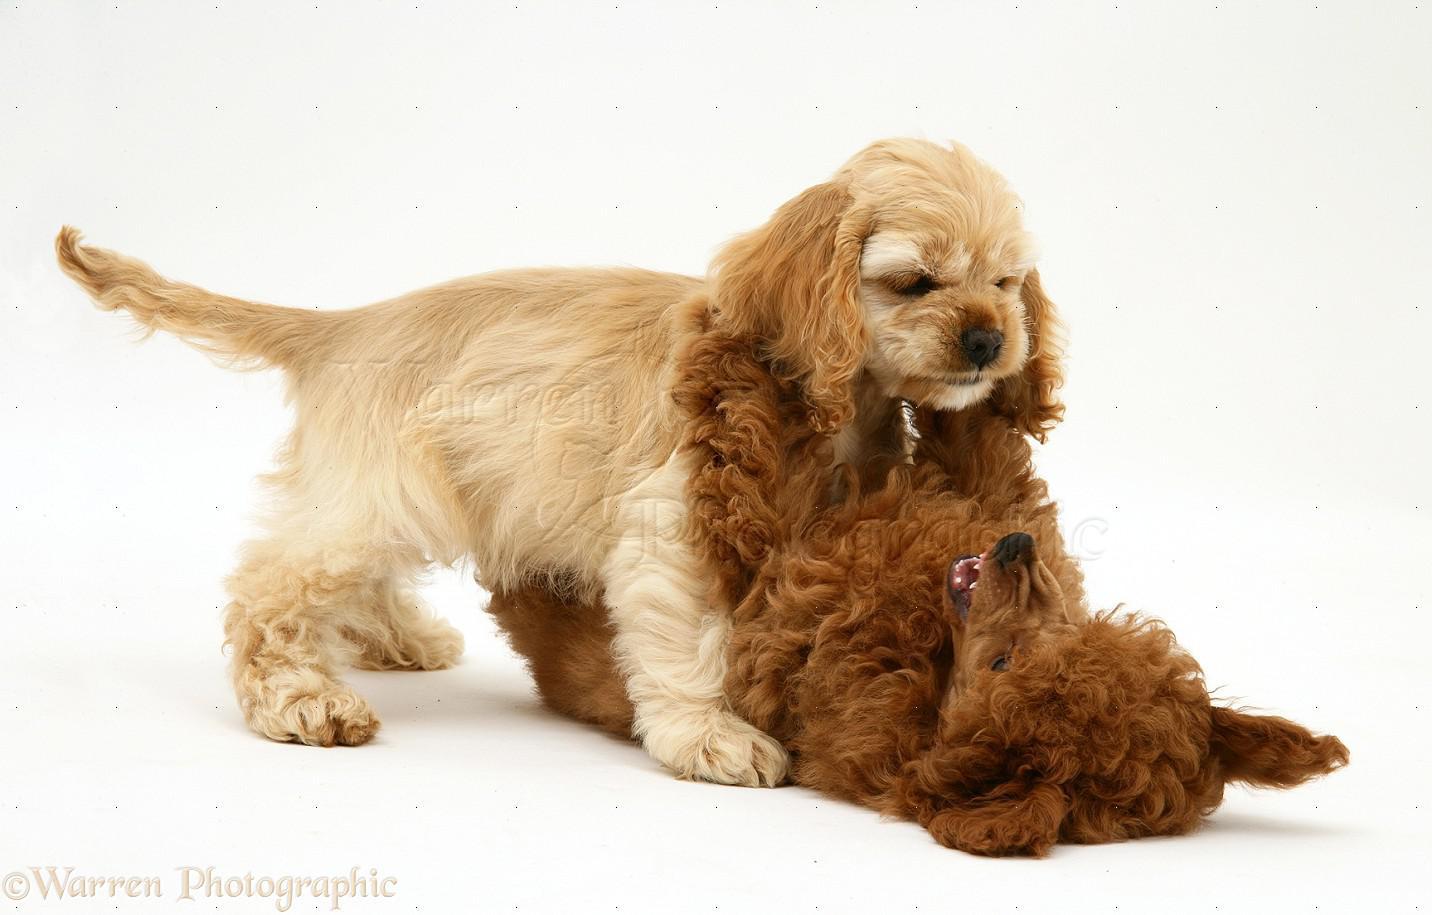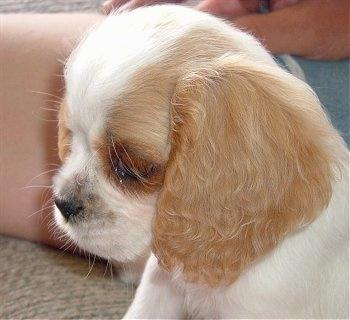The first image is the image on the left, the second image is the image on the right. Given the left and right images, does the statement "There is a young tan puppy on top of a curlyhaired brown puppy." hold true? Answer yes or no. Yes. The first image is the image on the left, the second image is the image on the right. Analyze the images presented: Is the assertion "There are two dogs in the left image." valid? Answer yes or no. Yes. 